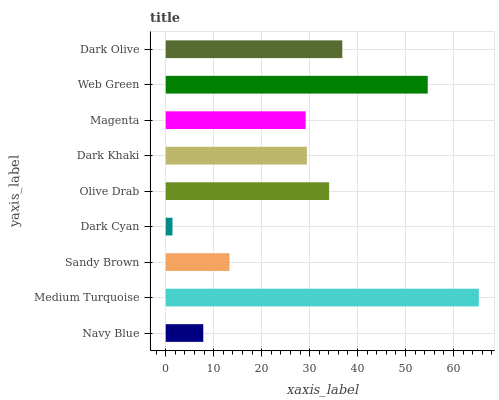Is Dark Cyan the minimum?
Answer yes or no. Yes. Is Medium Turquoise the maximum?
Answer yes or no. Yes. Is Sandy Brown the minimum?
Answer yes or no. No. Is Sandy Brown the maximum?
Answer yes or no. No. Is Medium Turquoise greater than Sandy Brown?
Answer yes or no. Yes. Is Sandy Brown less than Medium Turquoise?
Answer yes or no. Yes. Is Sandy Brown greater than Medium Turquoise?
Answer yes or no. No. Is Medium Turquoise less than Sandy Brown?
Answer yes or no. No. Is Dark Khaki the high median?
Answer yes or no. Yes. Is Dark Khaki the low median?
Answer yes or no. Yes. Is Magenta the high median?
Answer yes or no. No. Is Dark Cyan the low median?
Answer yes or no. No. 